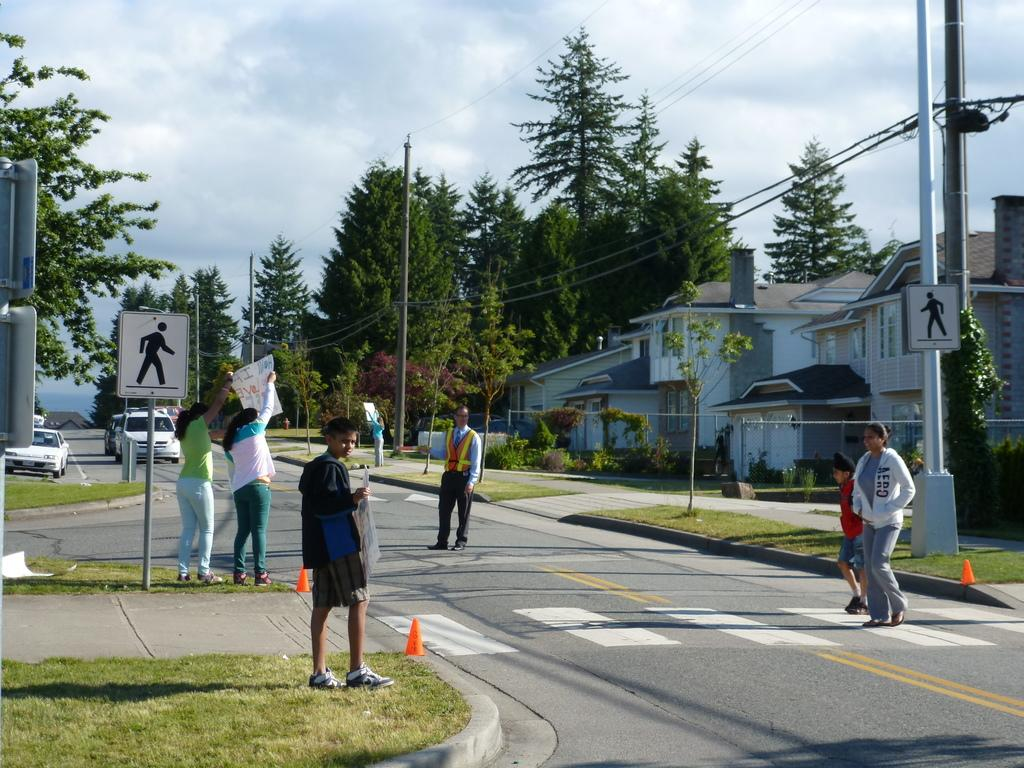What are the people in the image doing? There are many persons walking on the road in the image. What can be seen in the background of the image? There are trees, houses, poles, cars, and the sky visible in the background of the image. What is the condition of the sky in the image? The sky is visible in the background of the image, and there are clouds present. What type of boundary can be seen separating the houses in the image? There is no boundary visible between the houses in the image. What substance is being used by the people walking on the road in the image? There is no indication of any substance being used by the people walking on the road in the image. 